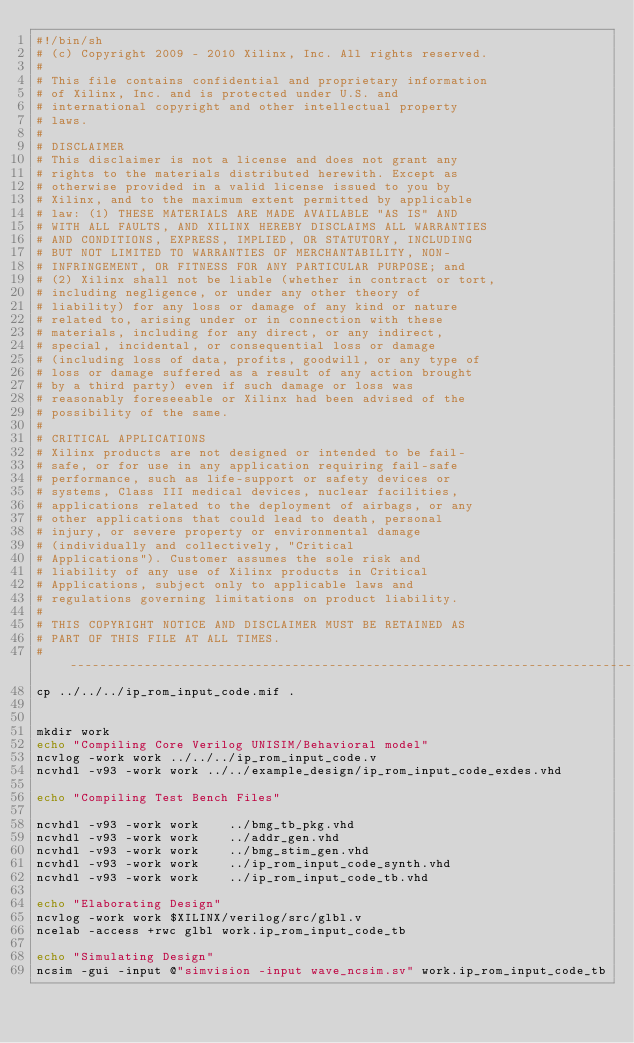Convert code to text. <code><loc_0><loc_0><loc_500><loc_500><_Bash_>#!/bin/sh
# (c) Copyright 2009 - 2010 Xilinx, Inc. All rights reserved.
# 
# This file contains confidential and proprietary information
# of Xilinx, Inc. and is protected under U.S. and
# international copyright and other intellectual property
# laws.
# 
# DISCLAIMER
# This disclaimer is not a license and does not grant any
# rights to the materials distributed herewith. Except as
# otherwise provided in a valid license issued to you by
# Xilinx, and to the maximum extent permitted by applicable
# law: (1) THESE MATERIALS ARE MADE AVAILABLE "AS IS" AND
# WITH ALL FAULTS, AND XILINX HEREBY DISCLAIMS ALL WARRANTIES
# AND CONDITIONS, EXPRESS, IMPLIED, OR STATUTORY, INCLUDING
# BUT NOT LIMITED TO WARRANTIES OF MERCHANTABILITY, NON-
# INFRINGEMENT, OR FITNESS FOR ANY PARTICULAR PURPOSE; and
# (2) Xilinx shall not be liable (whether in contract or tort,
# including negligence, or under any other theory of
# liability) for any loss or damage of any kind or nature
# related to, arising under or in connection with these
# materials, including for any direct, or any indirect,
# special, incidental, or consequential loss or damage
# (including loss of data, profits, goodwill, or any type of
# loss or damage suffered as a result of any action brought
# by a third party) even if such damage or loss was
# reasonably foreseeable or Xilinx had been advised of the
# possibility of the same.
# 
# CRITICAL APPLICATIONS
# Xilinx products are not designed or intended to be fail-
# safe, or for use in any application requiring fail-safe
# performance, such as life-support or safety devices or
# systems, Class III medical devices, nuclear facilities,
# applications related to the deployment of airbags, or any
# other applications that could lead to death, personal
# injury, or severe property or environmental damage
# (individually and collectively, "Critical
# Applications"). Customer assumes the sole risk and
# liability of any use of Xilinx products in Critical
# Applications, subject only to applicable laws and
# regulations governing limitations on product liability.
# 
# THIS COPYRIGHT NOTICE AND DISCLAIMER MUST BE RETAINED AS
# PART OF THIS FILE AT ALL TIMES.
#--------------------------------------------------------------------------------
cp ../../../ip_rom_input_code.mif .


mkdir work
echo "Compiling Core Verilog UNISIM/Behavioral model"
ncvlog -work work ../../../ip_rom_input_code.v 
ncvhdl -v93 -work work ../../example_design/ip_rom_input_code_exdes.vhd

echo "Compiling Test Bench Files"

ncvhdl -v93 -work work    ../bmg_tb_pkg.vhd
ncvhdl -v93 -work work    ../addr_gen.vhd
ncvhdl -v93 -work work    ../bmg_stim_gen.vhd
ncvhdl -v93 -work work    ../ip_rom_input_code_synth.vhd 
ncvhdl -v93 -work work    ../ip_rom_input_code_tb.vhd

echo "Elaborating Design"
ncvlog -work work $XILINX/verilog/src/glbl.v
ncelab -access +rwc glbl work.ip_rom_input_code_tb

echo "Simulating Design"
ncsim -gui -input @"simvision -input wave_ncsim.sv" work.ip_rom_input_code_tb
</code> 